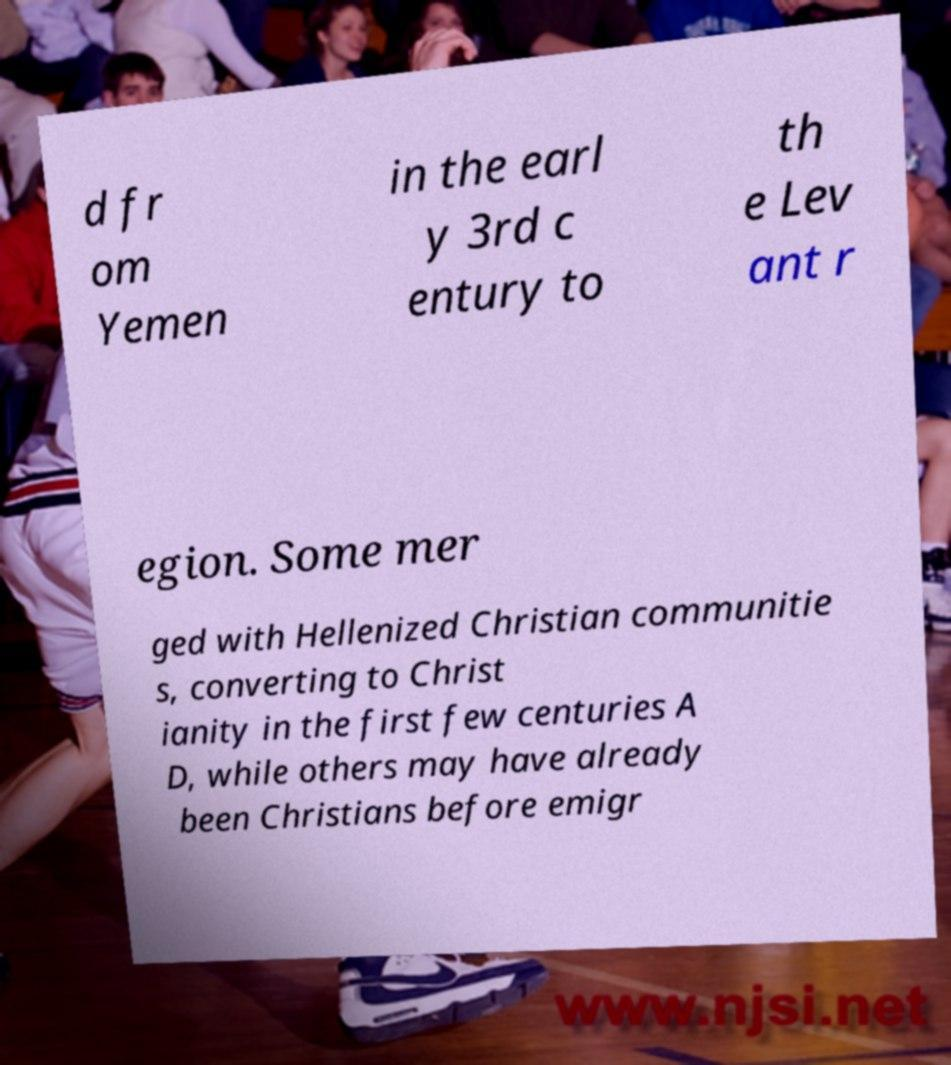Could you assist in decoding the text presented in this image and type it out clearly? d fr om Yemen in the earl y 3rd c entury to th e Lev ant r egion. Some mer ged with Hellenized Christian communitie s, converting to Christ ianity in the first few centuries A D, while others may have already been Christians before emigr 